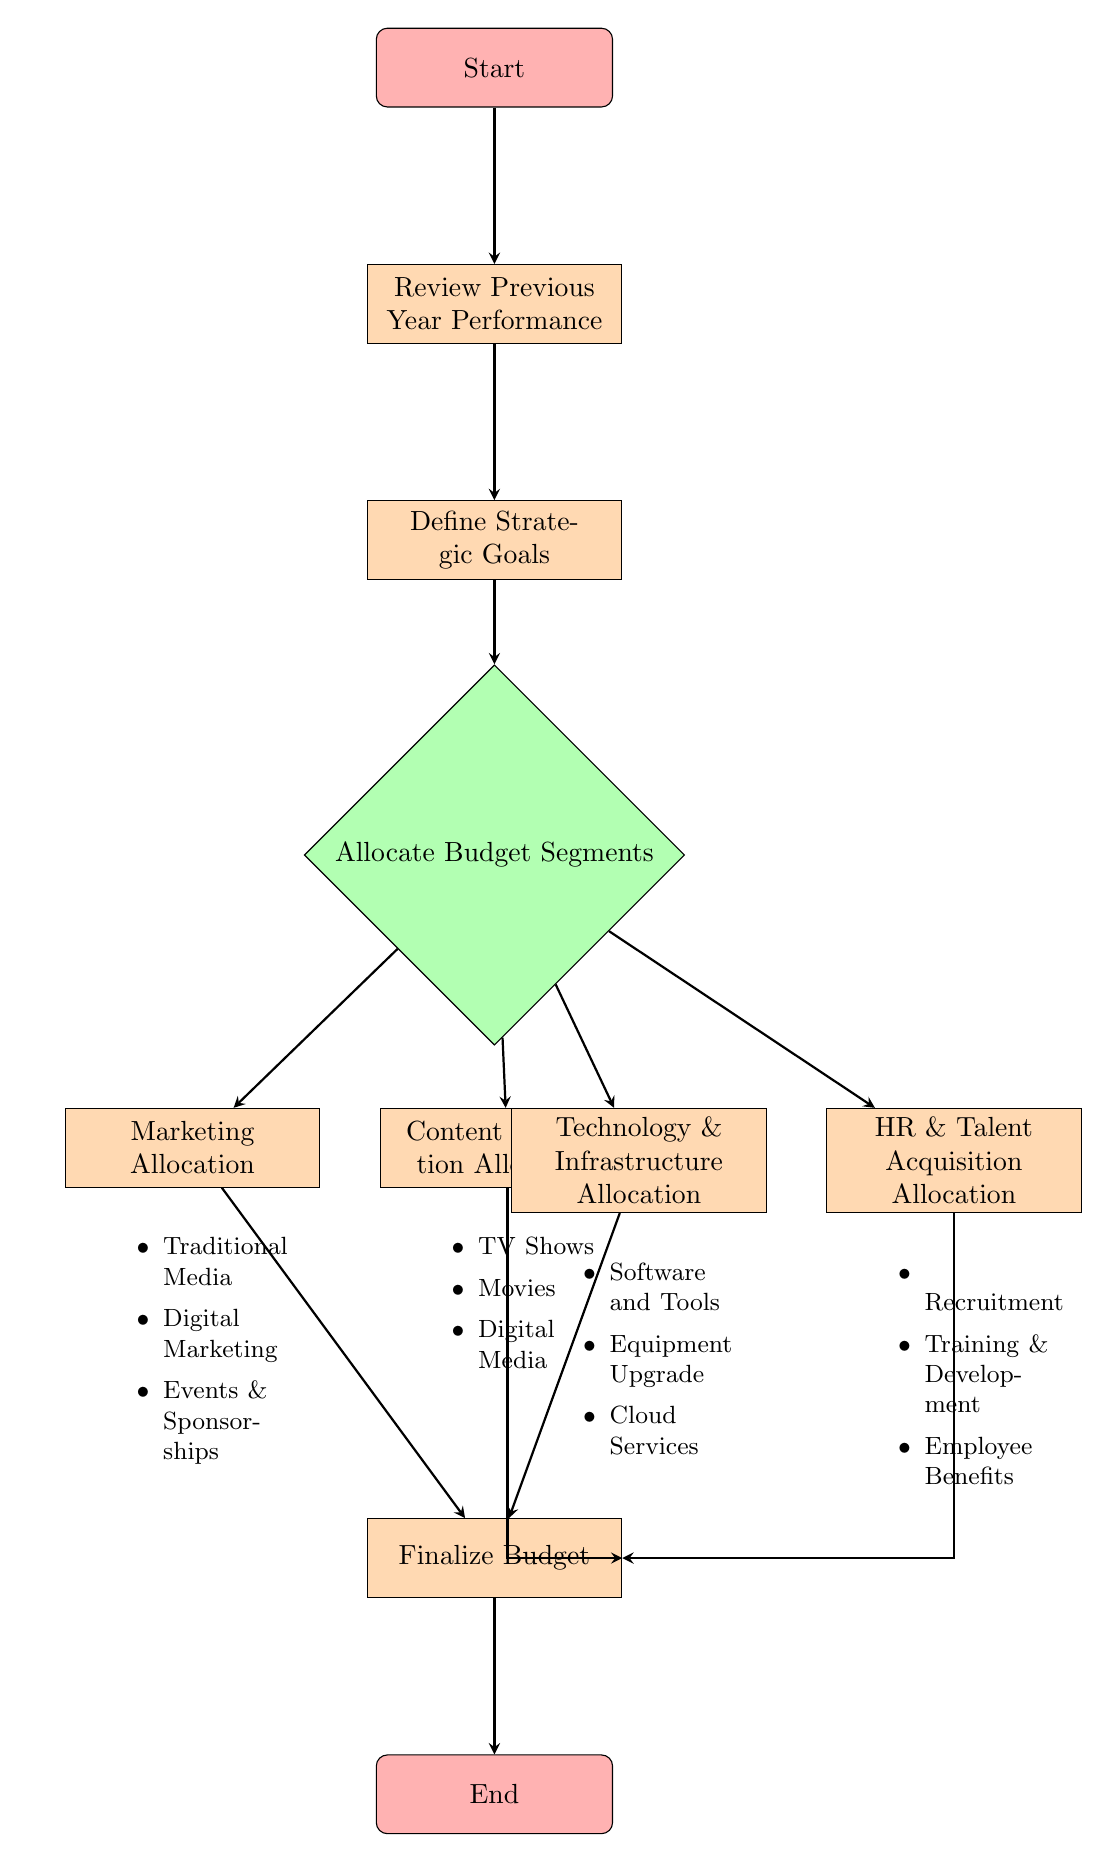What is the first node in the flow chart? The first node in the flow chart is labeled "Start," indicating the beginning of the budget allocation process.
Answer: Start How many main budget segments are allocated in the diagram? The diagram shows four main budget segments being allocated, which are Content Production, Marketing, Technology & Infrastructure, and HR & Talent Acquisition.
Answer: Four What node follows "Define Strategic Goals"? The node that follows "Define Strategic Goals" is "Allocate Budget Segments," which is the next step in the process of budget allocation.
Answer: Allocate Budget Segments Which node comes before the "Finalize Budget" node? The nodes that lead to "Finalize Budget" are the allocations from Content Production, Marketing, Technology & Infrastructure, and HR & Talent Acquisition. The last node before "Finalize Budget" is any of these but is most commonly seen after all allocations are completed.
Answer: Content Production Allocation, Marketing Allocation, Technology & Infrastructure Allocation, HR & Talent Acquisition Allocation List all options available for Marketing Allocation. The options available for Marketing Allocation as per the diagram are Traditional Media, Digital Marketing, and Events & Sponsorships, providing a breakdown of potential areas for marketing expenditures.
Answer: Traditional Media, Digital Marketing, Events & Sponsorships What are the last two nodes in the flow chart? The last two nodes in the flow chart are "Finalize Budget," which is the penultimate stage before approval, and "End," which signifies the conclusion of the budget allocation process.
Answer: Finalize Budget, End How many edges connect to the "Allocate Budget Segments" node? There are three edges connecting to the "Allocate Budget Segments" node, which include links from the nodes "Define Strategic Goals" and the four allocation nodes leading to "Finalize Budget."
Answer: Three What types of allocations are included under Technology & Infrastructure? Under Technology & Infrastructure allocation, the types include Software and Tools, Equipment Upgrade, and Cloud Services, indicating areas targeted for technological investment.
Answer: Software and Tools, Equipment Upgrade, Cloud Services How many options are available for HR & Talent Acquisition? There are three options available for HR & Talent Acquisition: Recruitment, Training & Development, and Employee Benefits, outlining the key focus areas for human resources in the budget.
Answer: Three 